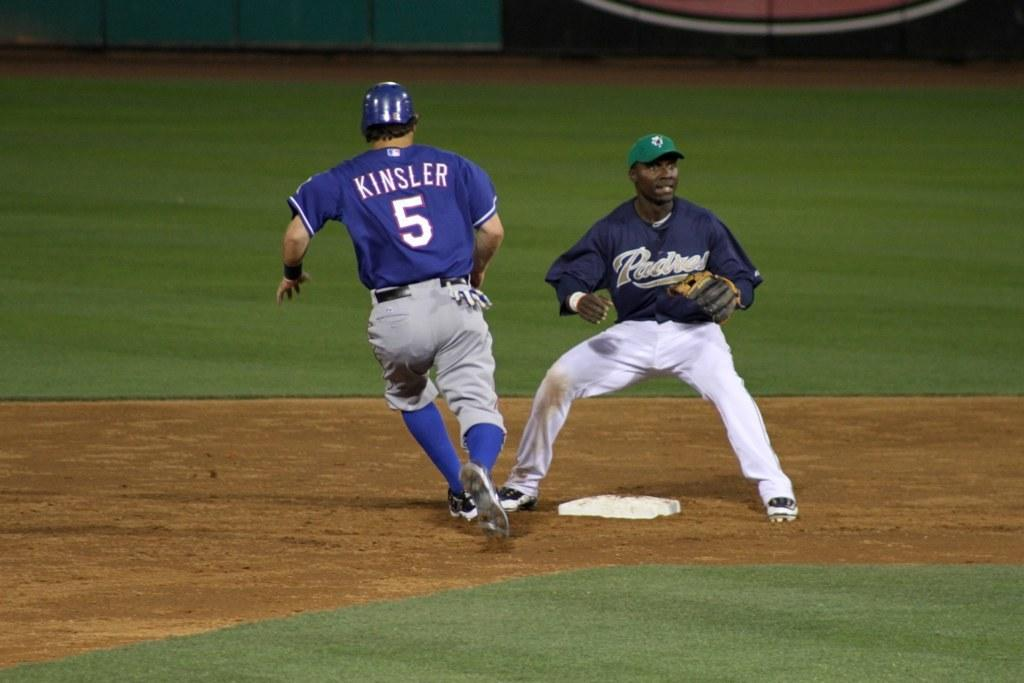<image>
Create a compact narrative representing the image presented. A baseball player named Kinsler rounds a base. 